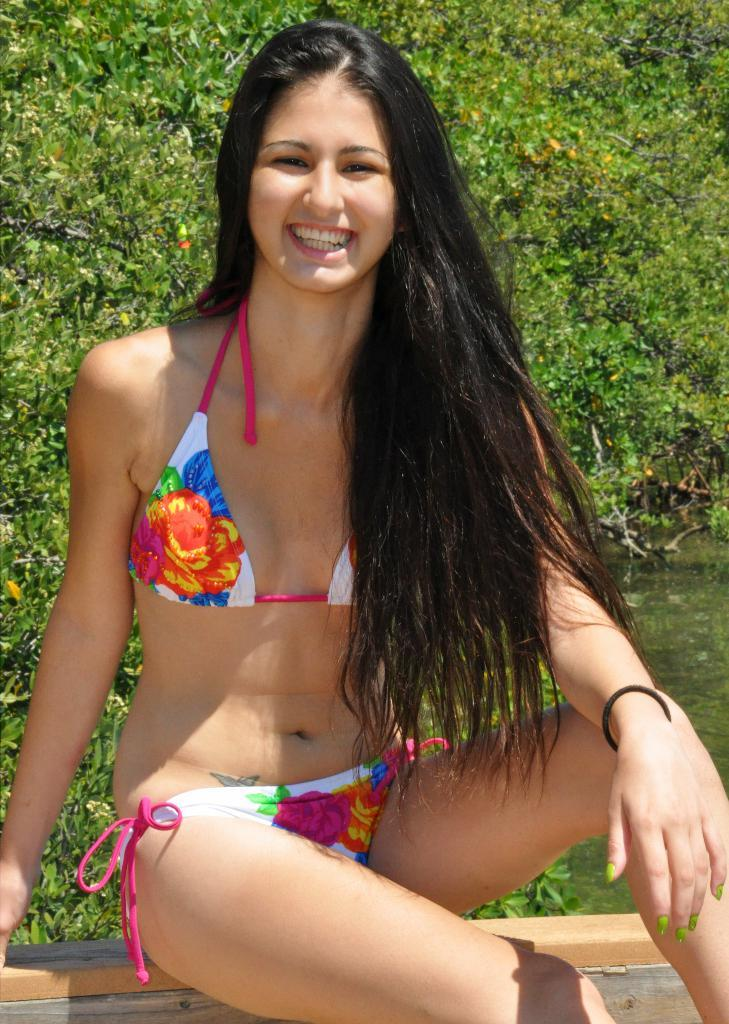Who is the main subject in the image? There is a girl in the image. What is the girl wearing? The girl is wearing a bikini. What is the girl doing in the image? The girl is sitting on a surface. What can be seen in the background of the image? There is water and trees visible in the background of the image. What type of glue is the girl using to stick the trees together in the image? There is no glue or text in the image, and the girl is not interacting with the trees in any way. 